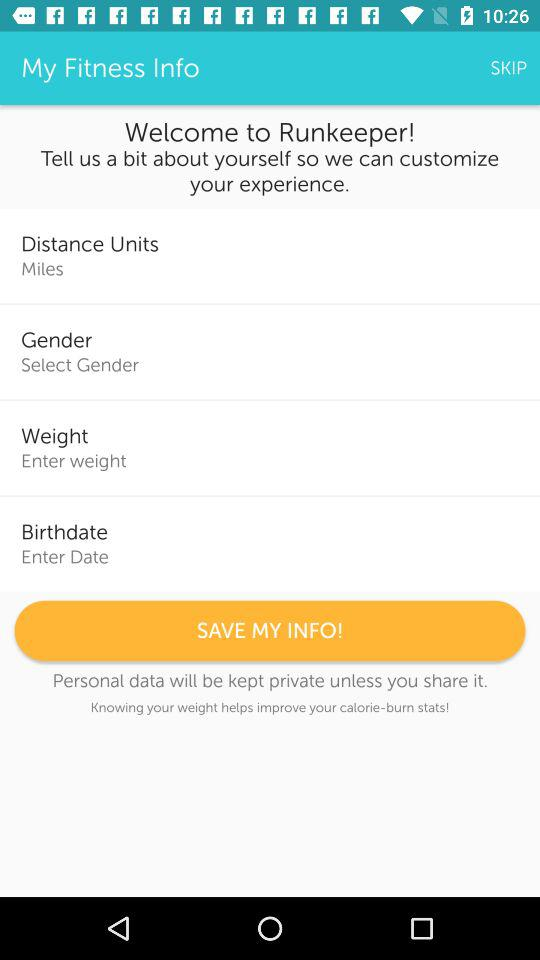What is the unit of distance? The unit of distance is miles. 